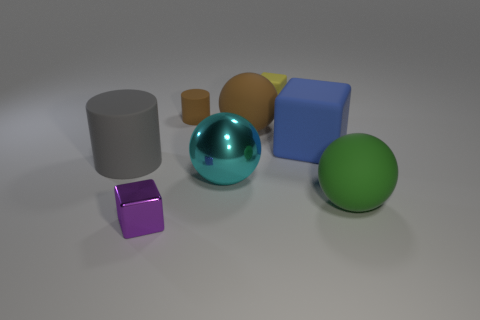Do the matte thing that is in front of the large metallic thing and the small rubber cube have the same color? no 